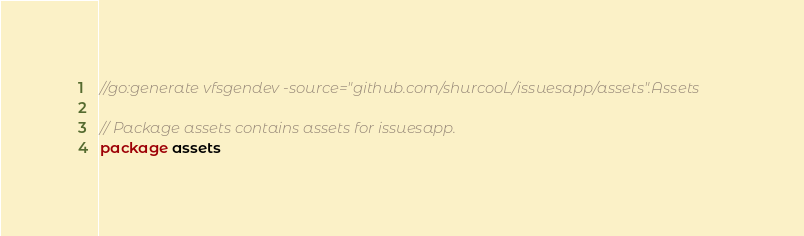Convert code to text. <code><loc_0><loc_0><loc_500><loc_500><_Go_>//go:generate vfsgendev -source="github.com/shurcooL/issuesapp/assets".Assets

// Package assets contains assets for issuesapp.
package assets
</code> 